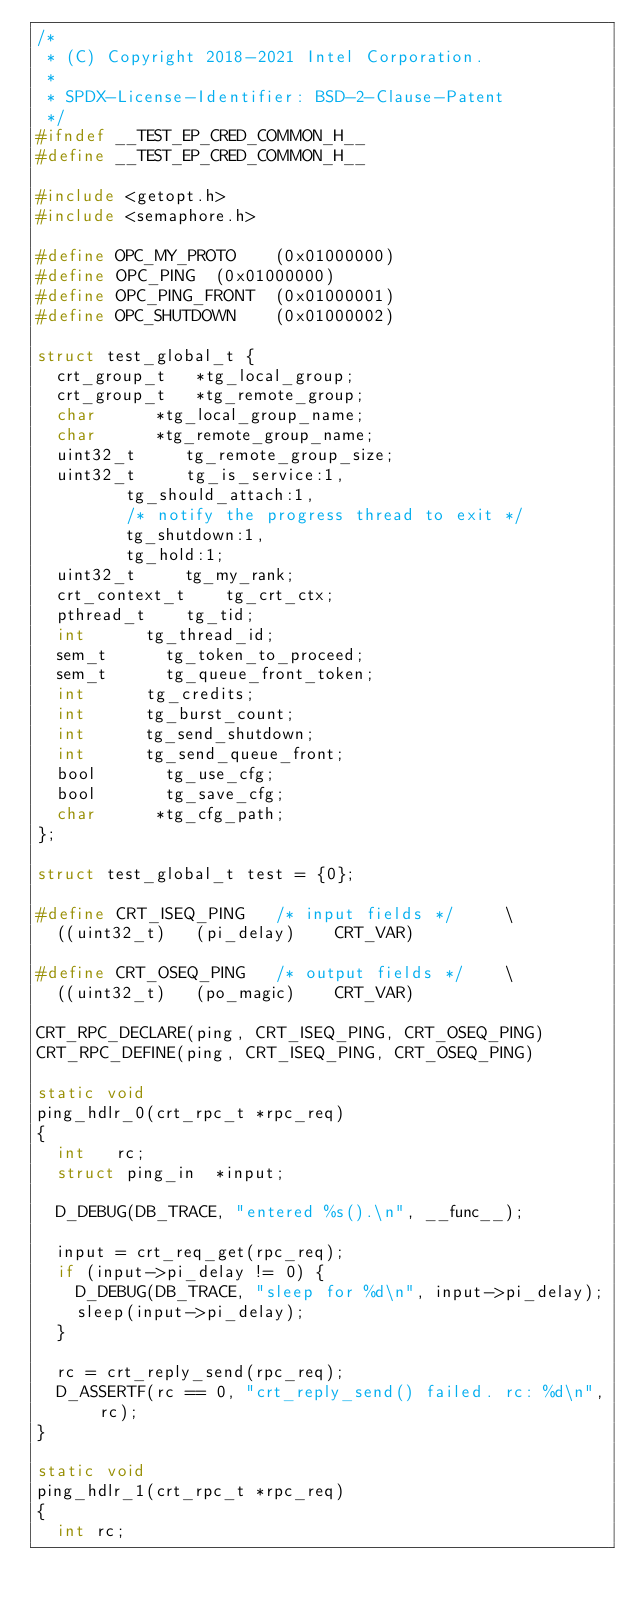Convert code to text. <code><loc_0><loc_0><loc_500><loc_500><_C_>/*
 * (C) Copyright 2018-2021 Intel Corporation.
 *
 * SPDX-License-Identifier: BSD-2-Clause-Patent
 */
#ifndef __TEST_EP_CRED_COMMON_H__
#define __TEST_EP_CRED_COMMON_H__

#include <getopt.h>
#include <semaphore.h>

#define OPC_MY_PROTO    (0x01000000)
#define OPC_PING	(0x01000000)
#define OPC_PING_FRONT	(0x01000001)
#define OPC_SHUTDOWN    (0x01000002)

struct test_global_t {
	crt_group_t		*tg_local_group;
	crt_group_t		*tg_remote_group;
	char			*tg_local_group_name;
	char			*tg_remote_group_name;
	uint32_t		 tg_remote_group_size;
	uint32_t		 tg_is_service:1,
				 tg_should_attach:1,
				 /* notify the progress thread to exit */
				 tg_shutdown:1,
				 tg_hold:1;
	uint32_t		 tg_my_rank;
	crt_context_t		 tg_crt_ctx;
	pthread_t		 tg_tid;
	int			 tg_thread_id;
	sem_t			 tg_token_to_proceed;
	sem_t			 tg_queue_front_token;
	int			 tg_credits;
	int			 tg_burst_count;
	int			 tg_send_shutdown;
	int			 tg_send_queue_front;
	bool			 tg_use_cfg;
	bool			 tg_save_cfg;
	char			*tg_cfg_path;
};

struct test_global_t test = {0};

#define CRT_ISEQ_PING		/* input fields */		 \
	((uint32_t)		(pi_delay)		CRT_VAR)

#define CRT_OSEQ_PING		/* output fields */		 \
	((uint32_t)		(po_magic)		CRT_VAR)

CRT_RPC_DECLARE(ping, CRT_ISEQ_PING, CRT_OSEQ_PING)
CRT_RPC_DEFINE(ping, CRT_ISEQ_PING, CRT_OSEQ_PING)

static void
ping_hdlr_0(crt_rpc_t *rpc_req)
{
	int		rc;
	struct ping_in	*input;

	D_DEBUG(DB_TRACE, "entered %s().\n", __func__);

	input = crt_req_get(rpc_req);
	if (input->pi_delay != 0) {
		D_DEBUG(DB_TRACE, "sleep for %d\n", input->pi_delay);
		sleep(input->pi_delay);
	}

	rc = crt_reply_send(rpc_req);
	D_ASSERTF(rc == 0, "crt_reply_send() failed. rc: %d\n", rc);
}

static void
ping_hdlr_1(crt_rpc_t *rpc_req)
{
	int rc;
</code> 